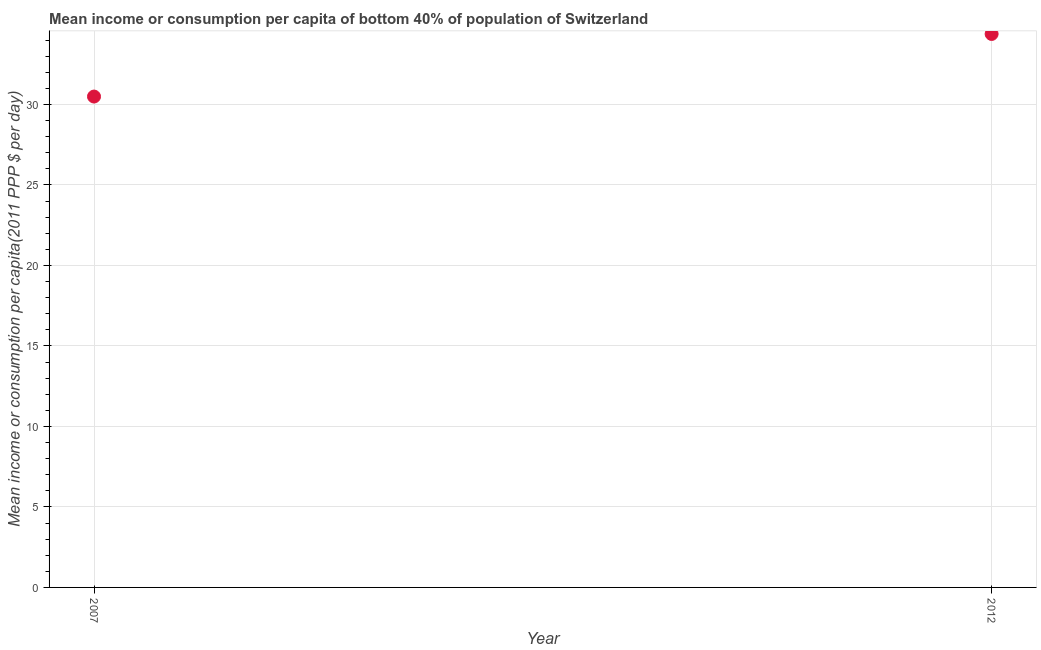What is the mean income or consumption in 2012?
Offer a terse response. 34.38. Across all years, what is the maximum mean income or consumption?
Your answer should be very brief. 34.38. Across all years, what is the minimum mean income or consumption?
Ensure brevity in your answer.  30.49. In which year was the mean income or consumption maximum?
Your answer should be very brief. 2012. In which year was the mean income or consumption minimum?
Your answer should be compact. 2007. What is the sum of the mean income or consumption?
Offer a terse response. 64.87. What is the difference between the mean income or consumption in 2007 and 2012?
Keep it short and to the point. -3.89. What is the average mean income or consumption per year?
Your answer should be very brief. 32.43. What is the median mean income or consumption?
Provide a succinct answer. 32.43. In how many years, is the mean income or consumption greater than 9 $?
Your response must be concise. 2. Do a majority of the years between 2012 and 2007 (inclusive) have mean income or consumption greater than 6 $?
Your response must be concise. No. What is the ratio of the mean income or consumption in 2007 to that in 2012?
Your response must be concise. 0.89. Is the mean income or consumption in 2007 less than that in 2012?
Give a very brief answer. Yes. Does the mean income or consumption monotonically increase over the years?
Your answer should be very brief. Yes. How many dotlines are there?
Give a very brief answer. 1. What is the difference between two consecutive major ticks on the Y-axis?
Your response must be concise. 5. Are the values on the major ticks of Y-axis written in scientific E-notation?
Make the answer very short. No. What is the title of the graph?
Give a very brief answer. Mean income or consumption per capita of bottom 40% of population of Switzerland. What is the label or title of the X-axis?
Provide a short and direct response. Year. What is the label or title of the Y-axis?
Give a very brief answer. Mean income or consumption per capita(2011 PPP $ per day). What is the Mean income or consumption per capita(2011 PPP $ per day) in 2007?
Make the answer very short. 30.49. What is the Mean income or consumption per capita(2011 PPP $ per day) in 2012?
Make the answer very short. 34.38. What is the difference between the Mean income or consumption per capita(2011 PPP $ per day) in 2007 and 2012?
Your response must be concise. -3.89. What is the ratio of the Mean income or consumption per capita(2011 PPP $ per day) in 2007 to that in 2012?
Provide a succinct answer. 0.89. 